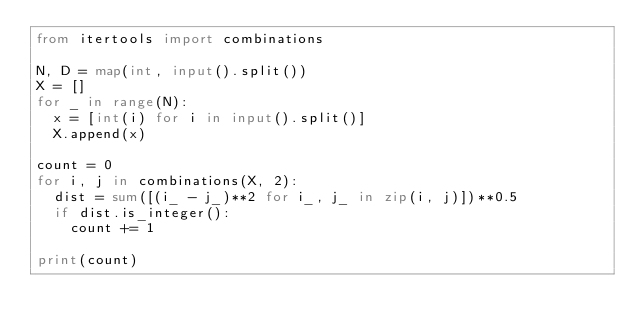<code> <loc_0><loc_0><loc_500><loc_500><_Python_>from itertools import combinations

N, D = map(int, input().split())
X = []
for _ in range(N):
  x = [int(i) for i in input().split()]
  X.append(x)
  
count = 0
for i, j in combinations(X, 2):
  dist = sum([(i_ - j_)**2 for i_, j_ in zip(i, j)])**0.5
  if dist.is_integer():
    count += 1

print(count)</code> 